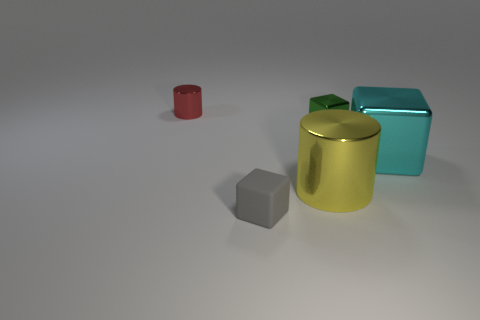Subtract all green shiny blocks. How many blocks are left? 2 Add 4 large blue rubber objects. How many objects exist? 9 Subtract all cylinders. How many objects are left? 3 Subtract 0 green balls. How many objects are left? 5 Subtract all tiny rubber blocks. Subtract all rubber objects. How many objects are left? 3 Add 3 small red objects. How many small red objects are left? 4 Add 5 gray things. How many gray things exist? 6 